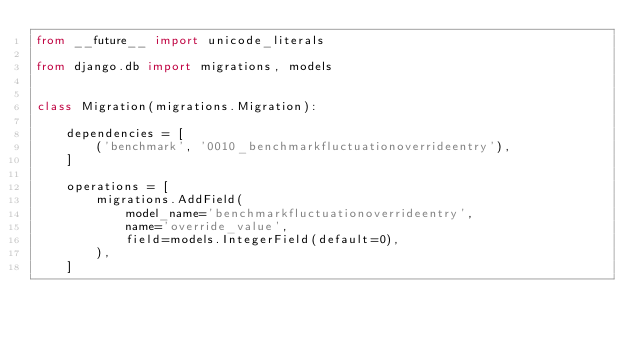Convert code to text. <code><loc_0><loc_0><loc_500><loc_500><_Python_>from __future__ import unicode_literals

from django.db import migrations, models


class Migration(migrations.Migration):

    dependencies = [
        ('benchmark', '0010_benchmarkfluctuationoverrideentry'),
    ]

    operations = [
        migrations.AddField(
            model_name='benchmarkfluctuationoverrideentry',
            name='override_value',
            field=models.IntegerField(default=0),
        ),
    ]
</code> 